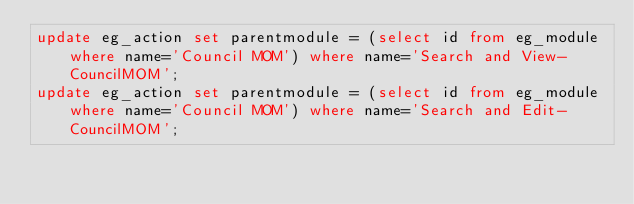Convert code to text. <code><loc_0><loc_0><loc_500><loc_500><_SQL_>update eg_action set parentmodule = (select id from eg_module where name='Council MOM') where name='Search and View-CouncilMOM';
update eg_action set parentmodule = (select id from eg_module where name='Council MOM') where name='Search and Edit-CouncilMOM';
</code> 